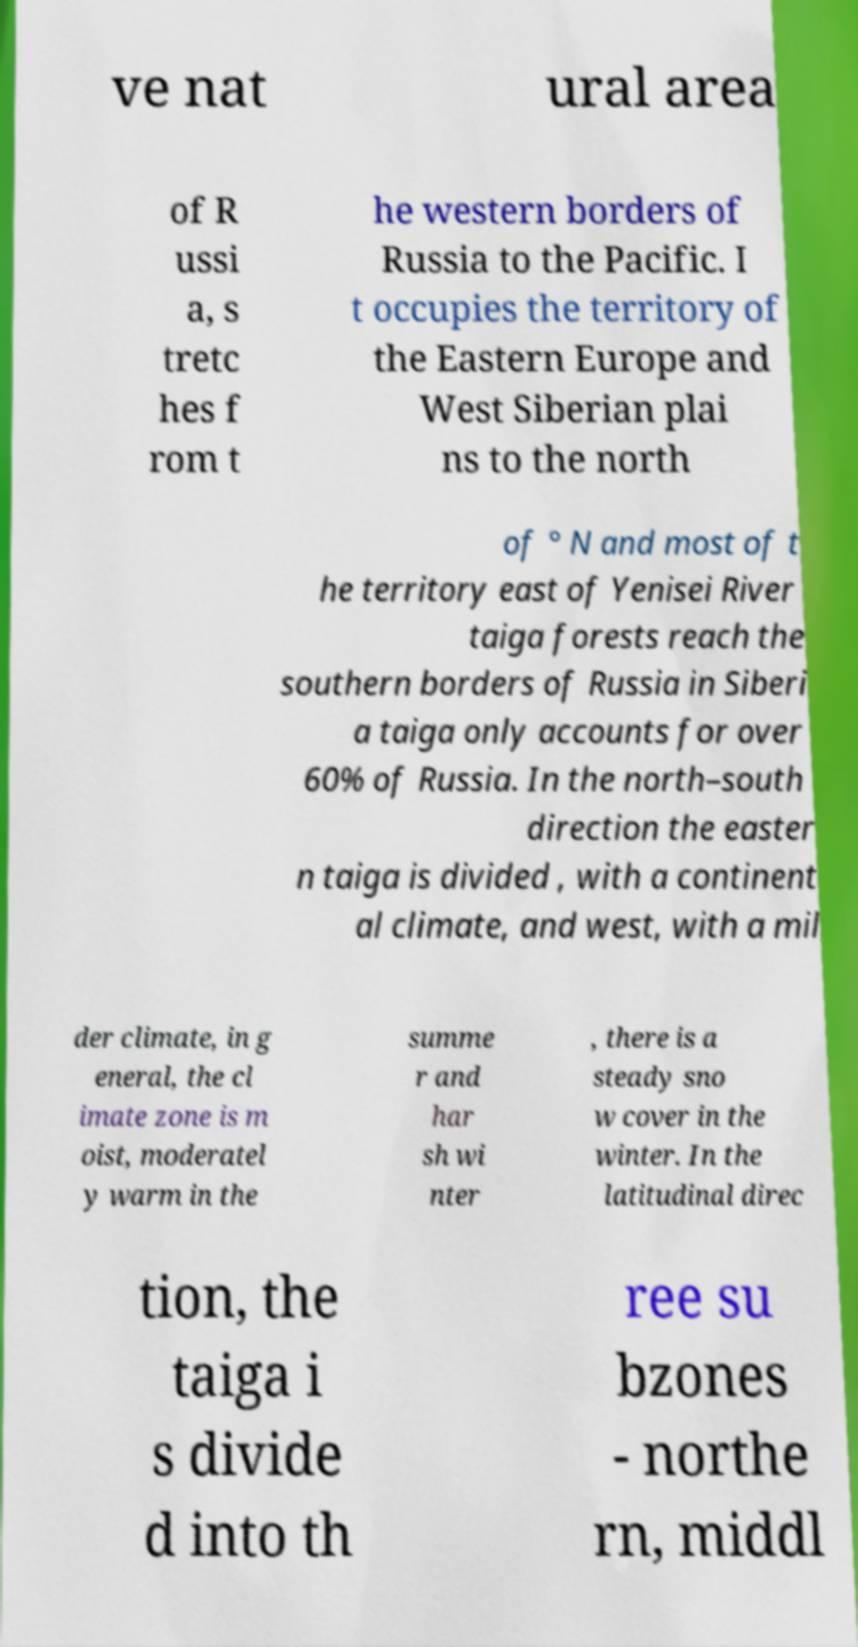There's text embedded in this image that I need extracted. Can you transcribe it verbatim? ve nat ural area of R ussi a, s tretc hes f rom t he western borders of Russia to the Pacific. I t occupies the territory of the Eastern Europe and West Siberian plai ns to the north of ° N and most of t he territory east of Yenisei River taiga forests reach the southern borders of Russia in Siberi a taiga only accounts for over 60% of Russia. In the north–south direction the easter n taiga is divided , with a continent al climate, and west, with a mil der climate, in g eneral, the cl imate zone is m oist, moderatel y warm in the summe r and har sh wi nter , there is a steady sno w cover in the winter. In the latitudinal direc tion, the taiga i s divide d into th ree su bzones - northe rn, middl 